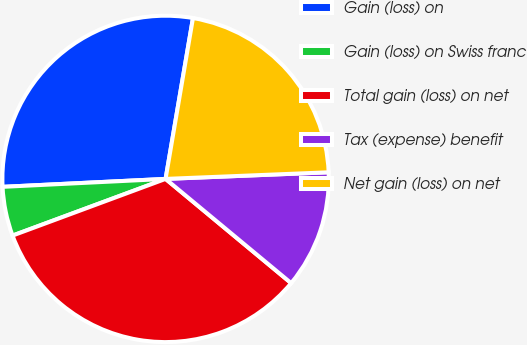Convert chart to OTSL. <chart><loc_0><loc_0><loc_500><loc_500><pie_chart><fcel>Gain (loss) on<fcel>Gain (loss) on Swiss franc<fcel>Total gain (loss) on net<fcel>Tax (expense) benefit<fcel>Net gain (loss) on net<nl><fcel>28.46%<fcel>4.87%<fcel>33.33%<fcel>11.67%<fcel>21.67%<nl></chart> 